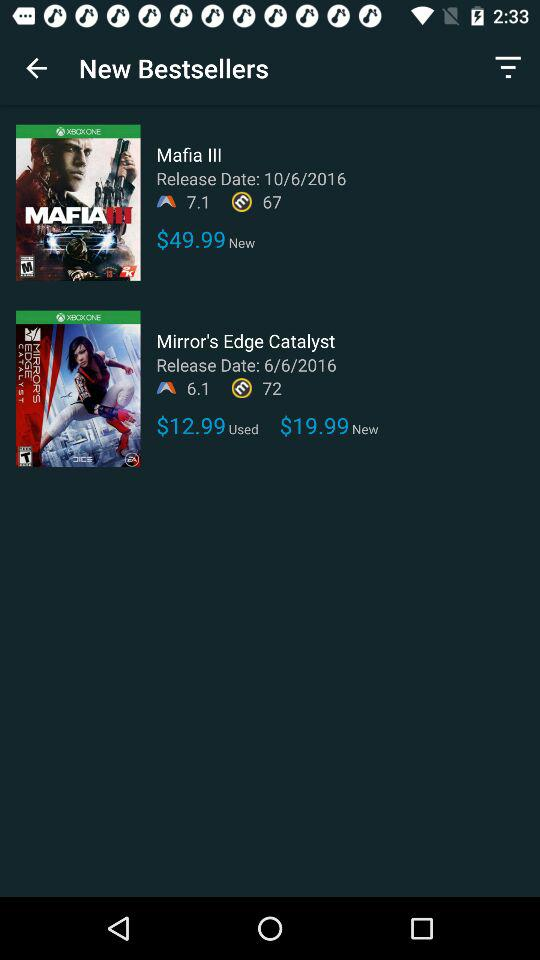What is the rating for "Mafia III"? The rating for "Mafia III" is 7.1. 